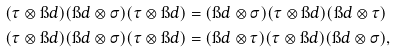<formula> <loc_0><loc_0><loc_500><loc_500>( \tau \otimes \i d ) ( \i d \otimes \sigma ) ( \tau \otimes \i d ) & = ( \i d \otimes \sigma ) ( \tau \otimes \i d ) ( \i d \otimes \tau ) \\ ( \tau \otimes \i d ) ( \i d \otimes \sigma ) ( \tau \otimes \i d ) & = ( \i d \otimes \tau ) ( \tau \otimes \i d ) ( \i d \otimes \sigma ) ,</formula> 